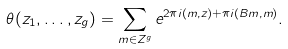Convert formula to latex. <formula><loc_0><loc_0><loc_500><loc_500>\theta ( z _ { 1 } , \dots , z _ { g } ) = \sum _ { m \in Z ^ { g } } e ^ { 2 \pi i ( m , z ) + \pi i ( B m , m ) } .</formula> 